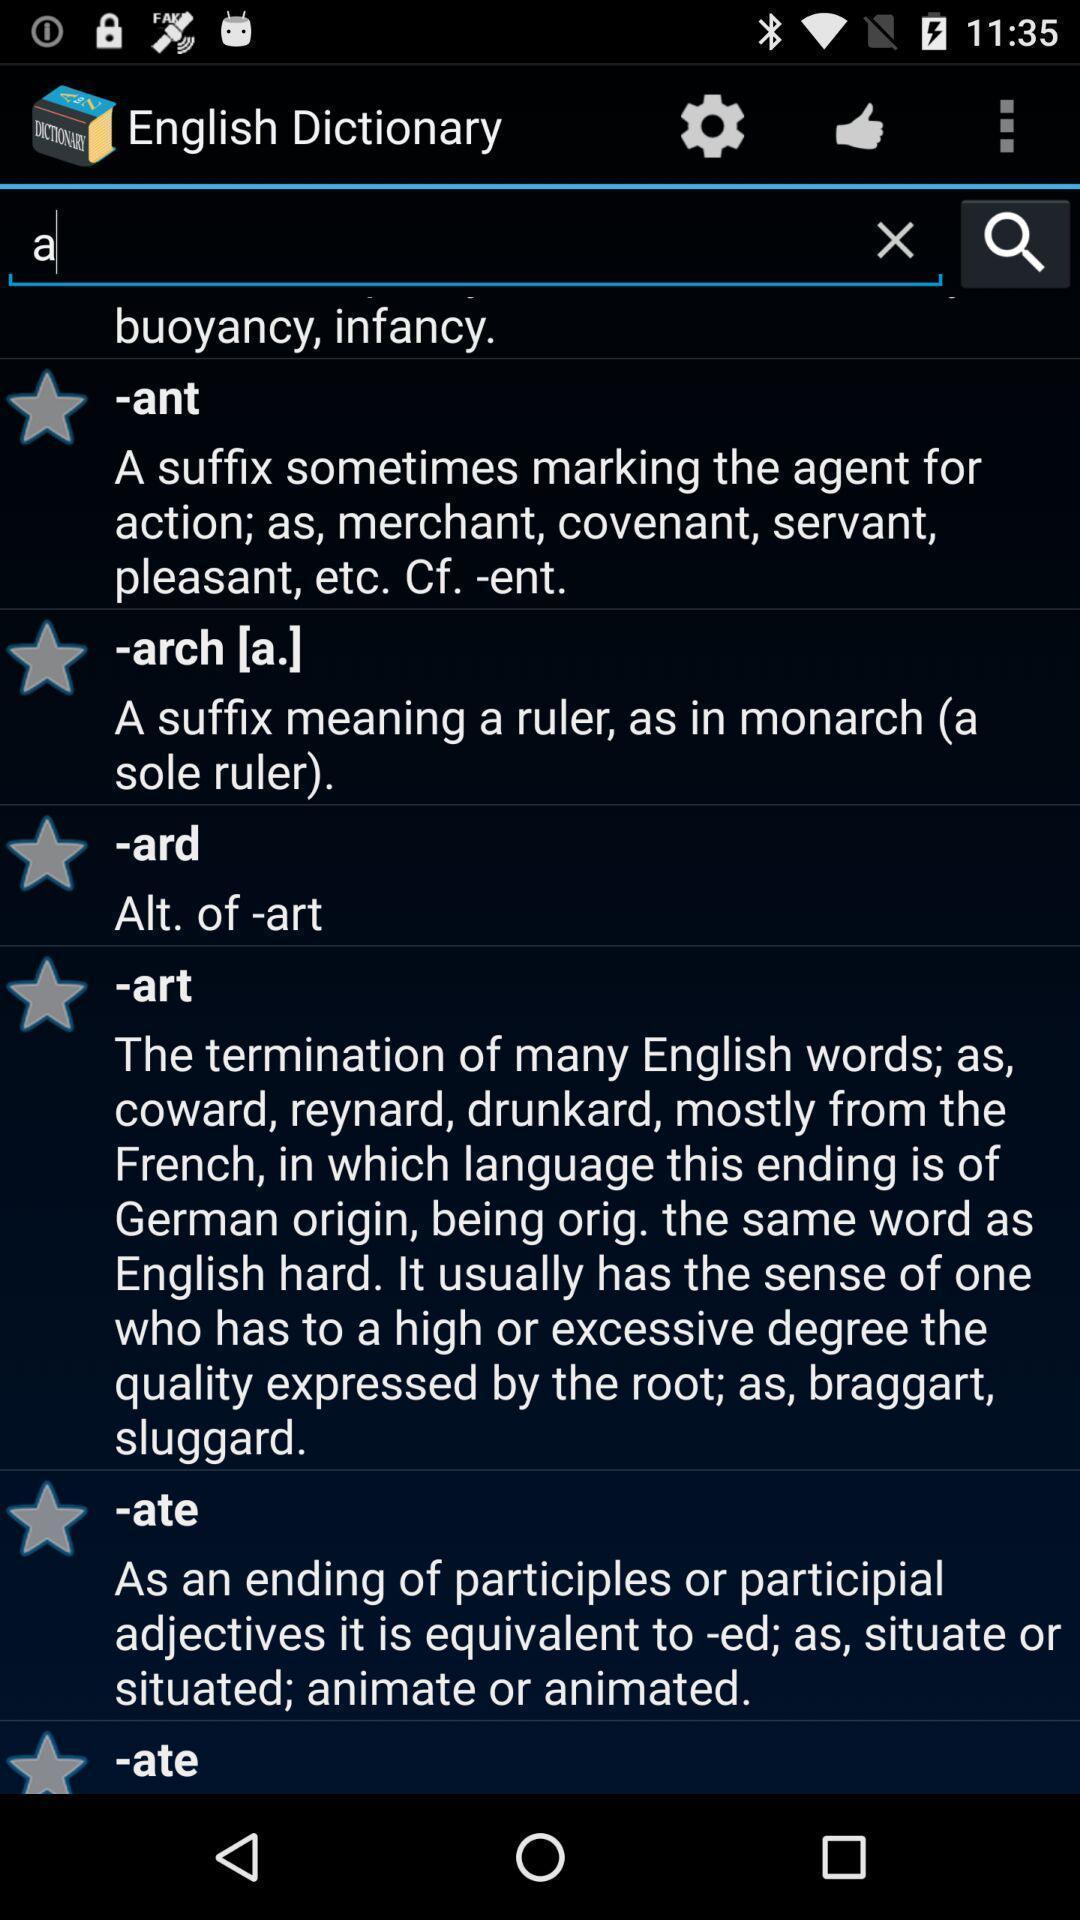Tell me about the visual elements in this screen capture. Page showing different words on a dictionary app. 